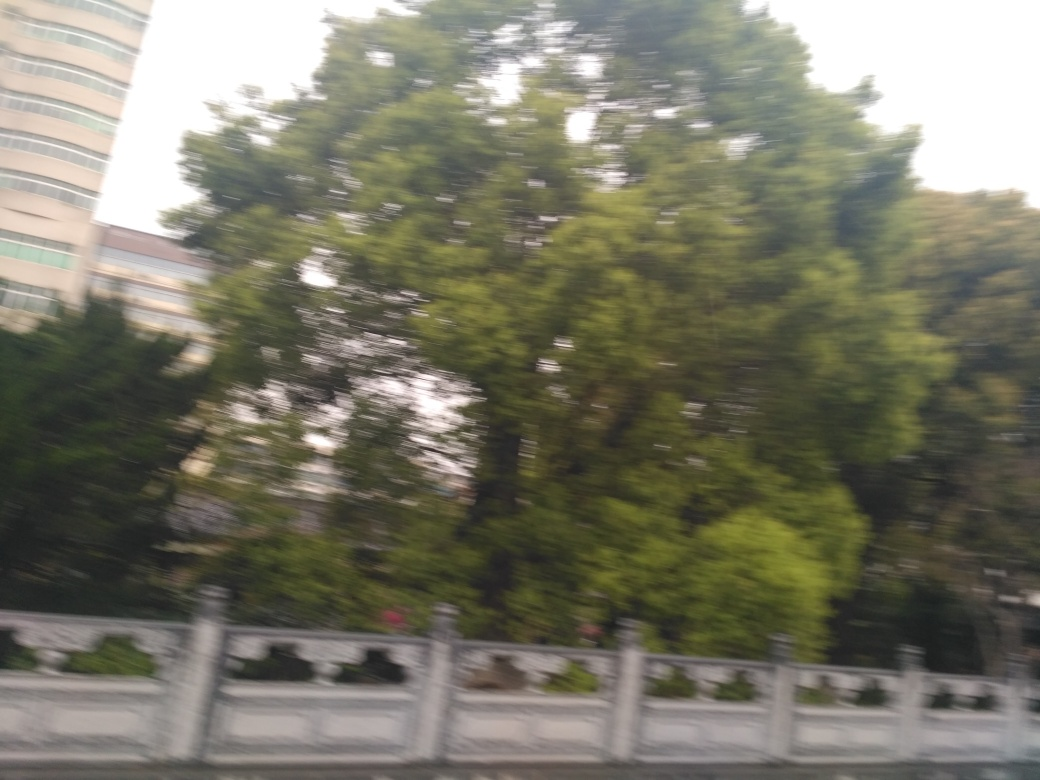What time of day does the image suggest? While the image is not perfectly clear, the quality of light and the shadows suggest it may have been taken during the daytime, potentially in the late afternoon, when the light has a soft, diffuse quality but is not yet at the golden hour. 